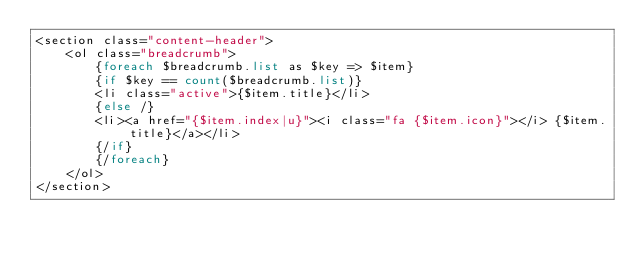<code> <loc_0><loc_0><loc_500><loc_500><_PHP_><section class="content-header">
    <ol class="breadcrumb">
        {foreach $breadcrumb.list as $key => $item}
        {if $key == count($breadcrumb.list)}
        <li class="active">{$item.title}</li>
        {else /}
        <li><a href="{$item.index|u}"><i class="fa {$item.icon}"></i> {$item.title}</a></li>
        {/if}
        {/foreach}
    </ol>
</section>
</code> 